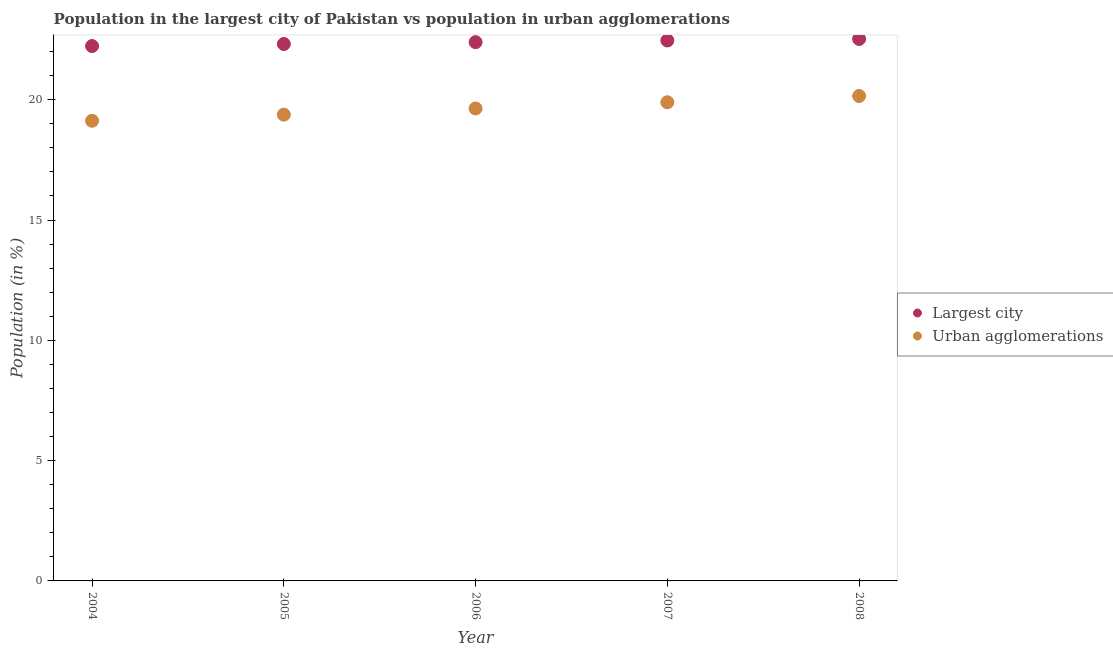What is the population in the largest city in 2007?
Keep it short and to the point. 22.46. Across all years, what is the maximum population in the largest city?
Your response must be concise. 22.52. Across all years, what is the minimum population in the largest city?
Your answer should be compact. 22.23. In which year was the population in urban agglomerations maximum?
Make the answer very short. 2008. In which year was the population in urban agglomerations minimum?
Your response must be concise. 2004. What is the total population in urban agglomerations in the graph?
Your response must be concise. 98.19. What is the difference between the population in urban agglomerations in 2005 and that in 2008?
Provide a succinct answer. -0.77. What is the difference between the population in urban agglomerations in 2007 and the population in the largest city in 2005?
Offer a very short reply. -2.42. What is the average population in urban agglomerations per year?
Your answer should be compact. 19.64. In the year 2008, what is the difference between the population in urban agglomerations and population in the largest city?
Your answer should be compact. -2.37. In how many years, is the population in urban agglomerations greater than 20 %?
Your answer should be compact. 1. What is the ratio of the population in urban agglomerations in 2005 to that in 2007?
Ensure brevity in your answer.  0.97. Is the population in urban agglomerations in 2004 less than that in 2006?
Ensure brevity in your answer.  Yes. What is the difference between the highest and the second highest population in urban agglomerations?
Ensure brevity in your answer.  0.26. What is the difference between the highest and the lowest population in urban agglomerations?
Your answer should be very brief. 1.03. Is the sum of the population in the largest city in 2006 and 2007 greater than the maximum population in urban agglomerations across all years?
Provide a succinct answer. Yes. Does the population in urban agglomerations monotonically increase over the years?
Your answer should be compact. Yes. Is the population in urban agglomerations strictly greater than the population in the largest city over the years?
Offer a terse response. No. Is the population in the largest city strictly less than the population in urban agglomerations over the years?
Your answer should be compact. No. How many dotlines are there?
Give a very brief answer. 2. What is the difference between two consecutive major ticks on the Y-axis?
Provide a short and direct response. 5. Are the values on the major ticks of Y-axis written in scientific E-notation?
Your response must be concise. No. Does the graph contain grids?
Ensure brevity in your answer.  No. What is the title of the graph?
Provide a succinct answer. Population in the largest city of Pakistan vs population in urban agglomerations. Does "Investment" appear as one of the legend labels in the graph?
Your response must be concise. No. What is the Population (in %) in Largest city in 2004?
Keep it short and to the point. 22.23. What is the Population (in %) of Urban agglomerations in 2004?
Offer a very short reply. 19.12. What is the Population (in %) in Largest city in 2005?
Your answer should be very brief. 22.31. What is the Population (in %) of Urban agglomerations in 2005?
Give a very brief answer. 19.38. What is the Population (in %) of Largest city in 2006?
Provide a short and direct response. 22.39. What is the Population (in %) in Urban agglomerations in 2006?
Offer a very short reply. 19.64. What is the Population (in %) in Largest city in 2007?
Your answer should be very brief. 22.46. What is the Population (in %) in Urban agglomerations in 2007?
Make the answer very short. 19.89. What is the Population (in %) of Largest city in 2008?
Your answer should be compact. 22.52. What is the Population (in %) of Urban agglomerations in 2008?
Offer a terse response. 20.15. Across all years, what is the maximum Population (in %) in Largest city?
Provide a short and direct response. 22.52. Across all years, what is the maximum Population (in %) of Urban agglomerations?
Offer a very short reply. 20.15. Across all years, what is the minimum Population (in %) in Largest city?
Your response must be concise. 22.23. Across all years, what is the minimum Population (in %) of Urban agglomerations?
Ensure brevity in your answer.  19.12. What is the total Population (in %) of Largest city in the graph?
Offer a terse response. 111.92. What is the total Population (in %) of Urban agglomerations in the graph?
Provide a short and direct response. 98.19. What is the difference between the Population (in %) of Largest city in 2004 and that in 2005?
Your answer should be compact. -0.08. What is the difference between the Population (in %) in Urban agglomerations in 2004 and that in 2005?
Your response must be concise. -0.25. What is the difference between the Population (in %) in Largest city in 2004 and that in 2006?
Your response must be concise. -0.16. What is the difference between the Population (in %) in Urban agglomerations in 2004 and that in 2006?
Provide a succinct answer. -0.51. What is the difference between the Population (in %) in Largest city in 2004 and that in 2007?
Give a very brief answer. -0.23. What is the difference between the Population (in %) in Urban agglomerations in 2004 and that in 2007?
Give a very brief answer. -0.77. What is the difference between the Population (in %) of Largest city in 2004 and that in 2008?
Your response must be concise. -0.29. What is the difference between the Population (in %) in Urban agglomerations in 2004 and that in 2008?
Your response must be concise. -1.03. What is the difference between the Population (in %) in Largest city in 2005 and that in 2006?
Provide a succinct answer. -0.08. What is the difference between the Population (in %) in Urban agglomerations in 2005 and that in 2006?
Ensure brevity in your answer.  -0.26. What is the difference between the Population (in %) in Largest city in 2005 and that in 2007?
Your response must be concise. -0.15. What is the difference between the Population (in %) of Urban agglomerations in 2005 and that in 2007?
Provide a short and direct response. -0.51. What is the difference between the Population (in %) of Largest city in 2005 and that in 2008?
Make the answer very short. -0.21. What is the difference between the Population (in %) in Urban agglomerations in 2005 and that in 2008?
Ensure brevity in your answer.  -0.77. What is the difference between the Population (in %) of Largest city in 2006 and that in 2007?
Give a very brief answer. -0.07. What is the difference between the Population (in %) in Urban agglomerations in 2006 and that in 2007?
Make the answer very short. -0.26. What is the difference between the Population (in %) in Largest city in 2006 and that in 2008?
Keep it short and to the point. -0.13. What is the difference between the Population (in %) in Urban agglomerations in 2006 and that in 2008?
Your answer should be very brief. -0.52. What is the difference between the Population (in %) of Largest city in 2007 and that in 2008?
Keep it short and to the point. -0.06. What is the difference between the Population (in %) in Urban agglomerations in 2007 and that in 2008?
Offer a very short reply. -0.26. What is the difference between the Population (in %) in Largest city in 2004 and the Population (in %) in Urban agglomerations in 2005?
Keep it short and to the point. 2.85. What is the difference between the Population (in %) in Largest city in 2004 and the Population (in %) in Urban agglomerations in 2006?
Ensure brevity in your answer.  2.6. What is the difference between the Population (in %) of Largest city in 2004 and the Population (in %) of Urban agglomerations in 2007?
Ensure brevity in your answer.  2.34. What is the difference between the Population (in %) in Largest city in 2004 and the Population (in %) in Urban agglomerations in 2008?
Provide a short and direct response. 2.08. What is the difference between the Population (in %) of Largest city in 2005 and the Population (in %) of Urban agglomerations in 2006?
Keep it short and to the point. 2.68. What is the difference between the Population (in %) in Largest city in 2005 and the Population (in %) in Urban agglomerations in 2007?
Provide a short and direct response. 2.42. What is the difference between the Population (in %) of Largest city in 2005 and the Population (in %) of Urban agglomerations in 2008?
Offer a terse response. 2.16. What is the difference between the Population (in %) in Largest city in 2006 and the Population (in %) in Urban agglomerations in 2007?
Keep it short and to the point. 2.5. What is the difference between the Population (in %) in Largest city in 2006 and the Population (in %) in Urban agglomerations in 2008?
Your response must be concise. 2.24. What is the difference between the Population (in %) of Largest city in 2007 and the Population (in %) of Urban agglomerations in 2008?
Your answer should be very brief. 2.31. What is the average Population (in %) of Largest city per year?
Ensure brevity in your answer.  22.38. What is the average Population (in %) of Urban agglomerations per year?
Make the answer very short. 19.64. In the year 2004, what is the difference between the Population (in %) of Largest city and Population (in %) of Urban agglomerations?
Your response must be concise. 3.11. In the year 2005, what is the difference between the Population (in %) in Largest city and Population (in %) in Urban agglomerations?
Provide a succinct answer. 2.94. In the year 2006, what is the difference between the Population (in %) of Largest city and Population (in %) of Urban agglomerations?
Provide a succinct answer. 2.76. In the year 2007, what is the difference between the Population (in %) of Largest city and Population (in %) of Urban agglomerations?
Provide a short and direct response. 2.57. In the year 2008, what is the difference between the Population (in %) in Largest city and Population (in %) in Urban agglomerations?
Give a very brief answer. 2.37. What is the ratio of the Population (in %) of Largest city in 2004 to that in 2005?
Provide a short and direct response. 1. What is the ratio of the Population (in %) in Urban agglomerations in 2004 to that in 2005?
Your answer should be compact. 0.99. What is the ratio of the Population (in %) in Largest city in 2004 to that in 2007?
Your answer should be very brief. 0.99. What is the ratio of the Population (in %) of Urban agglomerations in 2004 to that in 2007?
Make the answer very short. 0.96. What is the ratio of the Population (in %) of Urban agglomerations in 2004 to that in 2008?
Your response must be concise. 0.95. What is the ratio of the Population (in %) in Urban agglomerations in 2005 to that in 2007?
Your response must be concise. 0.97. What is the ratio of the Population (in %) in Largest city in 2005 to that in 2008?
Your response must be concise. 0.99. What is the ratio of the Population (in %) of Urban agglomerations in 2005 to that in 2008?
Offer a terse response. 0.96. What is the ratio of the Population (in %) of Urban agglomerations in 2006 to that in 2007?
Provide a short and direct response. 0.99. What is the ratio of the Population (in %) in Urban agglomerations in 2006 to that in 2008?
Provide a short and direct response. 0.97. What is the ratio of the Population (in %) of Largest city in 2007 to that in 2008?
Ensure brevity in your answer.  1. What is the ratio of the Population (in %) in Urban agglomerations in 2007 to that in 2008?
Keep it short and to the point. 0.99. What is the difference between the highest and the second highest Population (in %) in Largest city?
Keep it short and to the point. 0.06. What is the difference between the highest and the second highest Population (in %) of Urban agglomerations?
Provide a succinct answer. 0.26. What is the difference between the highest and the lowest Population (in %) of Largest city?
Give a very brief answer. 0.29. What is the difference between the highest and the lowest Population (in %) in Urban agglomerations?
Provide a short and direct response. 1.03. 